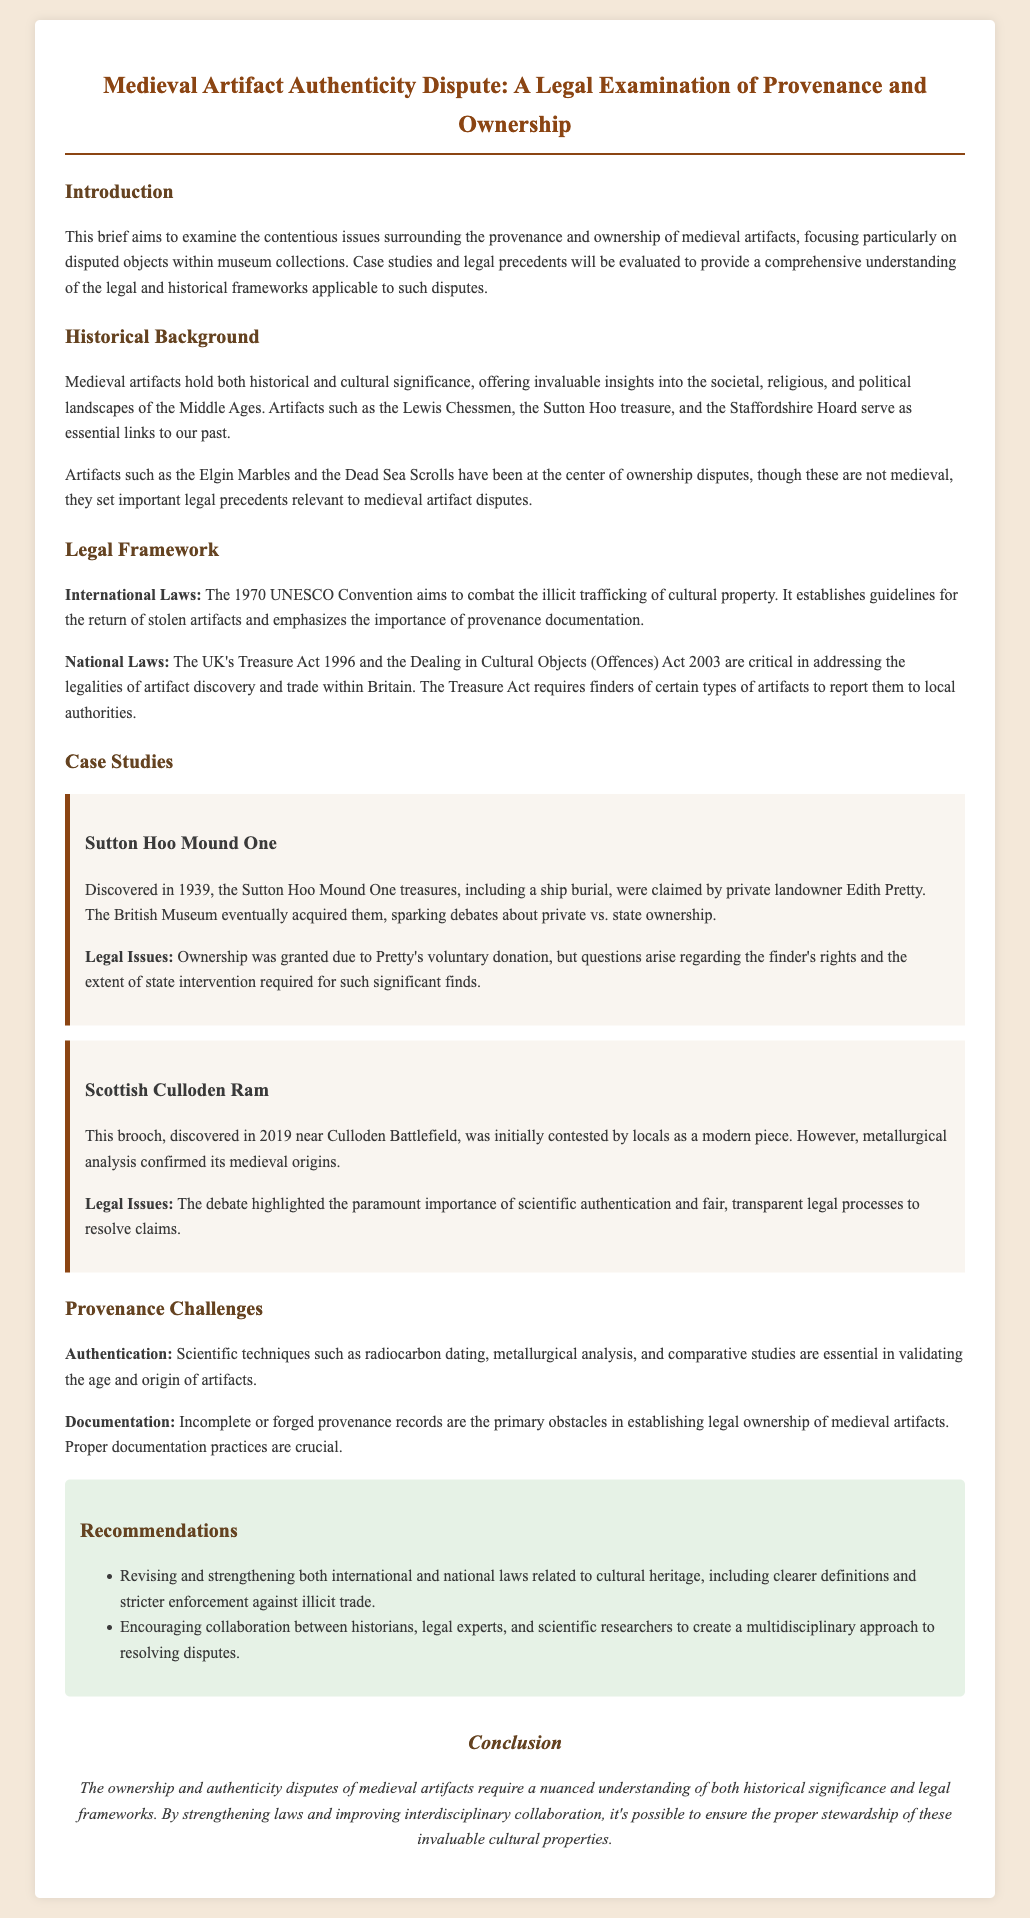what is the title of the document? The title is presented in the header section of the document, summarizing its main focus.
Answer: Medieval Artifact Authenticity Dispute: A Legal Examination of Provenance and Ownership what year was the Sutton Hoo Mound One discovered? The discovery year is mentioned in the case study section, providing context for the artifact's history.
Answer: 1939 what is the primary legal framework mentioned in international laws? The document discusses the role of international laws, specifically highlighting the relevant legal convention.
Answer: 1970 UNESCO Convention who was the private landowner associated with the Sutton Hoo treasures? The text directly identifies the individual linked to the acquisition of the artifacts in the case study.
Answer: Edith Pretty what scientific techniques are essential for authentication in provenance challenges? The document lists scientific methods that play a crucial role in confirming the authenticity of artifacts.
Answer: Radiocarbon dating what type of analysis confirmed the origins of the Culloden Ram brooch? This detail is found in the case study section, emphasizing the method used for authentication.
Answer: Metallurgical analysis what does the Treasure Act 1996 address? The Act is cited in the legal framework section, indicating its focus related to artifacts found within Britain.
Answer: Artifact discovery and trade which two entities are encouraged to collaborate in resolving disputes? The recommendations section emphasizes the collaboration needed among specific professional fields for effective resolution.
Answer: Historians and legal experts what is the conclusion about the ownership and authenticity disputes? The conclusion summarizes the overall assertion made in the legal brief regarding managing disputes.
Answer: Require a nuanced understanding of both historical significance and legal frameworks 